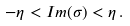<formula> <loc_0><loc_0><loc_500><loc_500>- \eta < I m ( \sigma ) < \eta \, .</formula> 